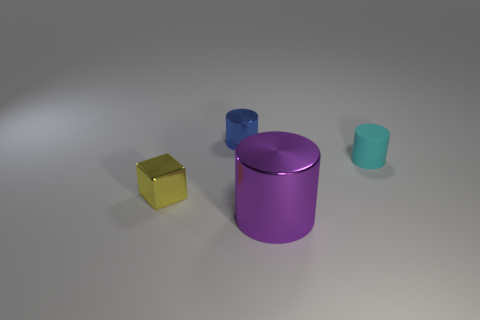Are any shiny cylinders visible?
Ensure brevity in your answer.  Yes. How big is the cylinder that is left of the small rubber object and behind the large cylinder?
Offer a very short reply. Small. There is a large purple object; what shape is it?
Offer a terse response. Cylinder. There is a metal thing to the left of the blue object; is there a blue shiny thing that is in front of it?
Keep it short and to the point. No. There is a cyan thing that is the same size as the yellow cube; what material is it?
Offer a very short reply. Rubber. Are there any cyan cylinders that have the same size as the yellow shiny object?
Make the answer very short. Yes. What is the material of the cylinder in front of the block?
Your answer should be compact. Metal. Is the material of the small cylinder that is to the right of the big purple cylinder the same as the blue cylinder?
Provide a short and direct response. No. There is another metal object that is the same size as the yellow thing; what shape is it?
Your answer should be very brief. Cylinder. What number of large objects have the same color as the cube?
Offer a very short reply. 0. 